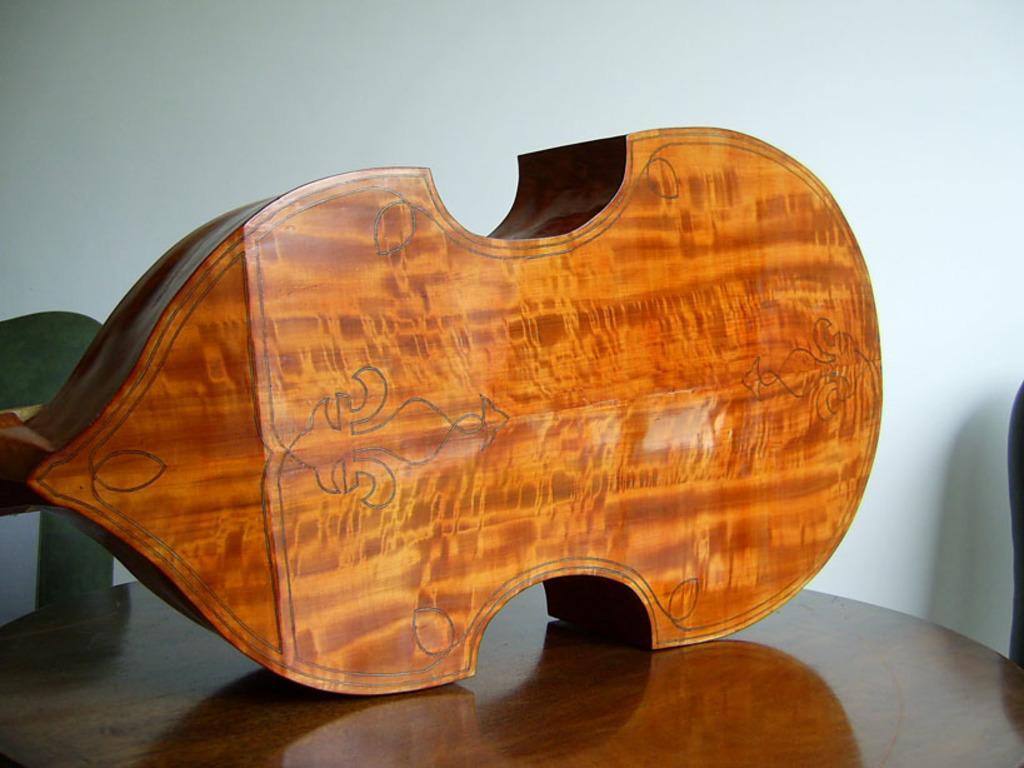Please provide a concise description of this image. In this image there is a wooden object on the table. Right side there is an object. Background there is a wall. 